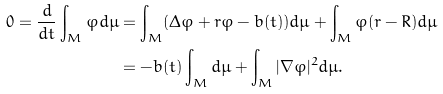<formula> <loc_0><loc_0><loc_500><loc_500>0 = \frac { d } { d t } \int _ { M } \varphi d \mu & = \int _ { M } ( \Delta \varphi + r \varphi - b ( t ) ) d \mu + \int _ { M } \varphi ( r - R ) d \mu \\ & = - b ( t ) \int _ { M } d \mu + \int _ { M } | \nabla \varphi | ^ { 2 } d \mu .</formula> 